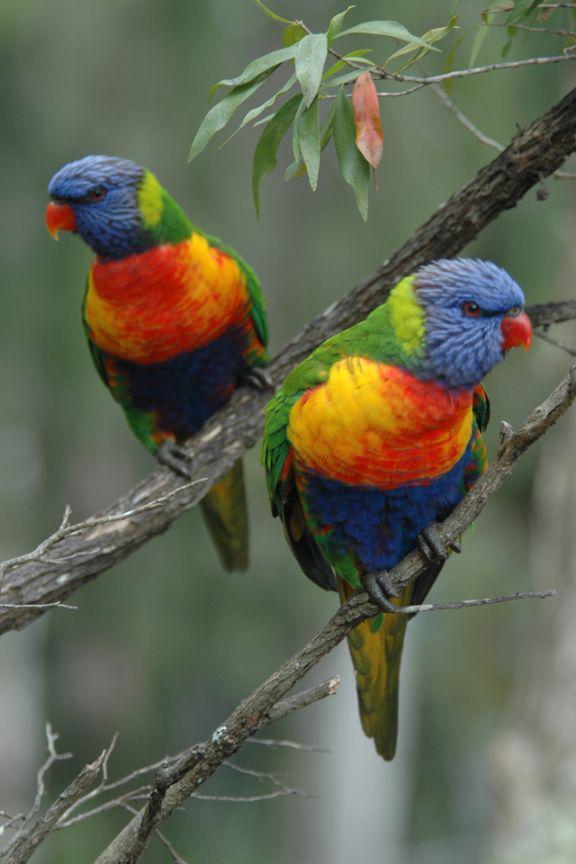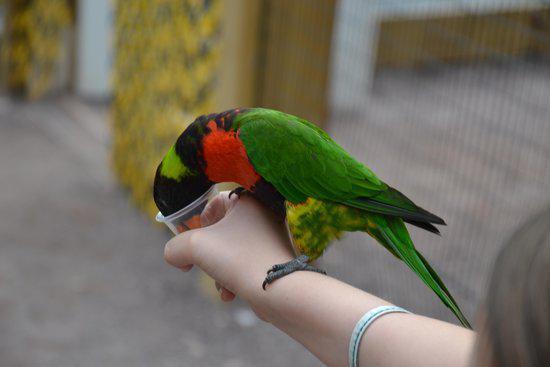The first image is the image on the left, the second image is the image on the right. For the images shown, is this caption "There are exactly two birds in one of the images." true? Answer yes or no. Yes. The first image is the image on the left, the second image is the image on the right. Analyze the images presented: Is the assertion "All birds have blue heads and are perched on a branch." valid? Answer yes or no. No. The first image is the image on the left, the second image is the image on the right. Analyze the images presented: Is the assertion "The left image contains at least three parrots." valid? Answer yes or no. No. The first image is the image on the left, the second image is the image on the right. For the images shown, is this caption "All green parrots have orange chest areas." true? Answer yes or no. Yes. 